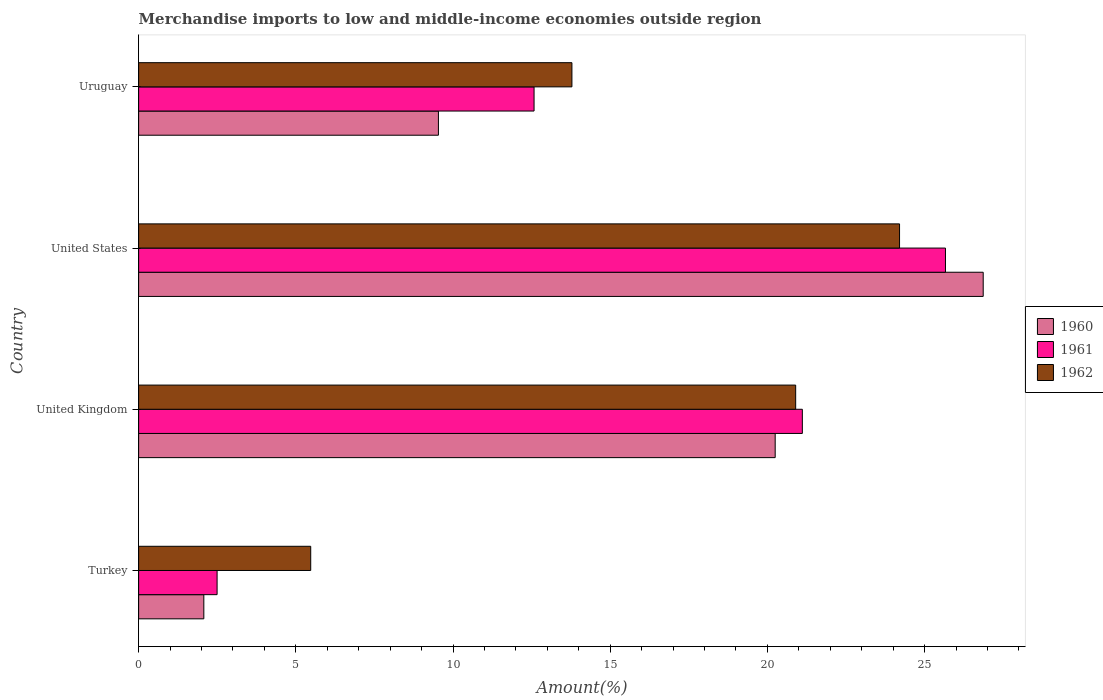How many groups of bars are there?
Your answer should be very brief. 4. How many bars are there on the 2nd tick from the top?
Offer a very short reply. 3. What is the label of the 2nd group of bars from the top?
Make the answer very short. United States. What is the percentage of amount earned from merchandise imports in 1960 in United Kingdom?
Keep it short and to the point. 20.25. Across all countries, what is the maximum percentage of amount earned from merchandise imports in 1961?
Your answer should be compact. 25.66. Across all countries, what is the minimum percentage of amount earned from merchandise imports in 1960?
Keep it short and to the point. 2.07. What is the total percentage of amount earned from merchandise imports in 1962 in the graph?
Give a very brief answer. 64.36. What is the difference between the percentage of amount earned from merchandise imports in 1960 in Turkey and that in Uruguay?
Ensure brevity in your answer.  -7.46. What is the difference between the percentage of amount earned from merchandise imports in 1961 in United States and the percentage of amount earned from merchandise imports in 1962 in Uruguay?
Ensure brevity in your answer.  11.88. What is the average percentage of amount earned from merchandise imports in 1962 per country?
Keep it short and to the point. 16.09. What is the difference between the percentage of amount earned from merchandise imports in 1960 and percentage of amount earned from merchandise imports in 1961 in Turkey?
Your answer should be very brief. -0.42. In how many countries, is the percentage of amount earned from merchandise imports in 1962 greater than 12 %?
Your answer should be very brief. 3. What is the ratio of the percentage of amount earned from merchandise imports in 1962 in United States to that in Uruguay?
Offer a terse response. 1.76. Is the percentage of amount earned from merchandise imports in 1962 in Turkey less than that in Uruguay?
Give a very brief answer. Yes. Is the difference between the percentage of amount earned from merchandise imports in 1960 in United Kingdom and Uruguay greater than the difference between the percentage of amount earned from merchandise imports in 1961 in United Kingdom and Uruguay?
Provide a succinct answer. Yes. What is the difference between the highest and the second highest percentage of amount earned from merchandise imports in 1962?
Give a very brief answer. 3.3. What is the difference between the highest and the lowest percentage of amount earned from merchandise imports in 1961?
Provide a short and direct response. 23.17. In how many countries, is the percentage of amount earned from merchandise imports in 1960 greater than the average percentage of amount earned from merchandise imports in 1960 taken over all countries?
Give a very brief answer. 2. Is the sum of the percentage of amount earned from merchandise imports in 1961 in United Kingdom and United States greater than the maximum percentage of amount earned from merchandise imports in 1960 across all countries?
Ensure brevity in your answer.  Yes. What does the 3rd bar from the bottom in United Kingdom represents?
Your answer should be compact. 1962. Is it the case that in every country, the sum of the percentage of amount earned from merchandise imports in 1962 and percentage of amount earned from merchandise imports in 1961 is greater than the percentage of amount earned from merchandise imports in 1960?
Make the answer very short. Yes. How many bars are there?
Provide a succinct answer. 12. Are all the bars in the graph horizontal?
Your response must be concise. Yes. How many countries are there in the graph?
Your answer should be very brief. 4. What is the difference between two consecutive major ticks on the X-axis?
Your answer should be compact. 5. Are the values on the major ticks of X-axis written in scientific E-notation?
Your answer should be very brief. No. Does the graph contain any zero values?
Ensure brevity in your answer.  No. Does the graph contain grids?
Your response must be concise. No. Where does the legend appear in the graph?
Give a very brief answer. Center right. What is the title of the graph?
Keep it short and to the point. Merchandise imports to low and middle-income economies outside region. Does "2010" appear as one of the legend labels in the graph?
Provide a short and direct response. No. What is the label or title of the X-axis?
Offer a terse response. Amount(%). What is the Amount(%) in 1960 in Turkey?
Ensure brevity in your answer.  2.07. What is the Amount(%) of 1961 in Turkey?
Ensure brevity in your answer.  2.5. What is the Amount(%) of 1962 in Turkey?
Your answer should be compact. 5.47. What is the Amount(%) in 1960 in United Kingdom?
Give a very brief answer. 20.25. What is the Amount(%) of 1961 in United Kingdom?
Provide a succinct answer. 21.11. What is the Amount(%) in 1962 in United Kingdom?
Keep it short and to the point. 20.9. What is the Amount(%) of 1960 in United States?
Your answer should be very brief. 26.86. What is the Amount(%) of 1961 in United States?
Your response must be concise. 25.66. What is the Amount(%) in 1962 in United States?
Provide a succinct answer. 24.2. What is the Amount(%) in 1960 in Uruguay?
Offer a terse response. 9.54. What is the Amount(%) in 1961 in Uruguay?
Your answer should be very brief. 12.58. What is the Amount(%) in 1962 in Uruguay?
Provide a succinct answer. 13.78. Across all countries, what is the maximum Amount(%) of 1960?
Offer a very short reply. 26.86. Across all countries, what is the maximum Amount(%) of 1961?
Provide a short and direct response. 25.66. Across all countries, what is the maximum Amount(%) in 1962?
Offer a terse response. 24.2. Across all countries, what is the minimum Amount(%) in 1960?
Make the answer very short. 2.07. Across all countries, what is the minimum Amount(%) in 1961?
Your answer should be very brief. 2.5. Across all countries, what is the minimum Amount(%) of 1962?
Make the answer very short. 5.47. What is the total Amount(%) of 1960 in the graph?
Keep it short and to the point. 58.72. What is the total Amount(%) of 1961 in the graph?
Your answer should be very brief. 61.85. What is the total Amount(%) of 1962 in the graph?
Give a very brief answer. 64.36. What is the difference between the Amount(%) of 1960 in Turkey and that in United Kingdom?
Your answer should be very brief. -18.17. What is the difference between the Amount(%) in 1961 in Turkey and that in United Kingdom?
Keep it short and to the point. -18.62. What is the difference between the Amount(%) of 1962 in Turkey and that in United Kingdom?
Make the answer very short. -15.43. What is the difference between the Amount(%) of 1960 in Turkey and that in United States?
Provide a succinct answer. -24.79. What is the difference between the Amount(%) of 1961 in Turkey and that in United States?
Provide a short and direct response. -23.17. What is the difference between the Amount(%) in 1962 in Turkey and that in United States?
Give a very brief answer. -18.73. What is the difference between the Amount(%) in 1960 in Turkey and that in Uruguay?
Your response must be concise. -7.46. What is the difference between the Amount(%) in 1961 in Turkey and that in Uruguay?
Keep it short and to the point. -10.08. What is the difference between the Amount(%) in 1962 in Turkey and that in Uruguay?
Keep it short and to the point. -8.31. What is the difference between the Amount(%) of 1960 in United Kingdom and that in United States?
Give a very brief answer. -6.62. What is the difference between the Amount(%) in 1961 in United Kingdom and that in United States?
Your answer should be very brief. -4.55. What is the difference between the Amount(%) of 1962 in United Kingdom and that in United States?
Make the answer very short. -3.3. What is the difference between the Amount(%) in 1960 in United Kingdom and that in Uruguay?
Offer a terse response. 10.71. What is the difference between the Amount(%) of 1961 in United Kingdom and that in Uruguay?
Your response must be concise. 8.53. What is the difference between the Amount(%) in 1962 in United Kingdom and that in Uruguay?
Keep it short and to the point. 7.12. What is the difference between the Amount(%) of 1960 in United States and that in Uruguay?
Offer a terse response. 17.33. What is the difference between the Amount(%) in 1961 in United States and that in Uruguay?
Ensure brevity in your answer.  13.09. What is the difference between the Amount(%) in 1962 in United States and that in Uruguay?
Your response must be concise. 10.42. What is the difference between the Amount(%) of 1960 in Turkey and the Amount(%) of 1961 in United Kingdom?
Your response must be concise. -19.04. What is the difference between the Amount(%) in 1960 in Turkey and the Amount(%) in 1962 in United Kingdom?
Ensure brevity in your answer.  -18.83. What is the difference between the Amount(%) in 1961 in Turkey and the Amount(%) in 1962 in United Kingdom?
Make the answer very short. -18.4. What is the difference between the Amount(%) in 1960 in Turkey and the Amount(%) in 1961 in United States?
Your answer should be very brief. -23.59. What is the difference between the Amount(%) of 1960 in Turkey and the Amount(%) of 1962 in United States?
Provide a short and direct response. -22.13. What is the difference between the Amount(%) of 1961 in Turkey and the Amount(%) of 1962 in United States?
Your answer should be compact. -21.71. What is the difference between the Amount(%) in 1960 in Turkey and the Amount(%) in 1961 in Uruguay?
Your response must be concise. -10.5. What is the difference between the Amount(%) of 1960 in Turkey and the Amount(%) of 1962 in Uruguay?
Keep it short and to the point. -11.71. What is the difference between the Amount(%) of 1961 in Turkey and the Amount(%) of 1962 in Uruguay?
Your answer should be very brief. -11.29. What is the difference between the Amount(%) in 1960 in United Kingdom and the Amount(%) in 1961 in United States?
Give a very brief answer. -5.42. What is the difference between the Amount(%) of 1960 in United Kingdom and the Amount(%) of 1962 in United States?
Ensure brevity in your answer.  -3.96. What is the difference between the Amount(%) in 1961 in United Kingdom and the Amount(%) in 1962 in United States?
Your answer should be very brief. -3.09. What is the difference between the Amount(%) of 1960 in United Kingdom and the Amount(%) of 1961 in Uruguay?
Your response must be concise. 7.67. What is the difference between the Amount(%) in 1960 in United Kingdom and the Amount(%) in 1962 in Uruguay?
Keep it short and to the point. 6.47. What is the difference between the Amount(%) of 1961 in United Kingdom and the Amount(%) of 1962 in Uruguay?
Your answer should be compact. 7.33. What is the difference between the Amount(%) in 1960 in United States and the Amount(%) in 1961 in Uruguay?
Your answer should be very brief. 14.29. What is the difference between the Amount(%) of 1960 in United States and the Amount(%) of 1962 in Uruguay?
Offer a terse response. 13.08. What is the difference between the Amount(%) in 1961 in United States and the Amount(%) in 1962 in Uruguay?
Your answer should be compact. 11.88. What is the average Amount(%) of 1960 per country?
Provide a succinct answer. 14.68. What is the average Amount(%) in 1961 per country?
Give a very brief answer. 15.46. What is the average Amount(%) in 1962 per country?
Give a very brief answer. 16.09. What is the difference between the Amount(%) of 1960 and Amount(%) of 1961 in Turkey?
Your answer should be compact. -0.42. What is the difference between the Amount(%) of 1960 and Amount(%) of 1962 in Turkey?
Ensure brevity in your answer.  -3.4. What is the difference between the Amount(%) in 1961 and Amount(%) in 1962 in Turkey?
Your response must be concise. -2.98. What is the difference between the Amount(%) in 1960 and Amount(%) in 1961 in United Kingdom?
Offer a very short reply. -0.86. What is the difference between the Amount(%) of 1960 and Amount(%) of 1962 in United Kingdom?
Provide a succinct answer. -0.65. What is the difference between the Amount(%) in 1961 and Amount(%) in 1962 in United Kingdom?
Provide a short and direct response. 0.21. What is the difference between the Amount(%) in 1960 and Amount(%) in 1961 in United States?
Your response must be concise. 1.2. What is the difference between the Amount(%) in 1960 and Amount(%) in 1962 in United States?
Offer a terse response. 2.66. What is the difference between the Amount(%) of 1961 and Amount(%) of 1962 in United States?
Your answer should be very brief. 1.46. What is the difference between the Amount(%) in 1960 and Amount(%) in 1961 in Uruguay?
Make the answer very short. -3.04. What is the difference between the Amount(%) of 1960 and Amount(%) of 1962 in Uruguay?
Make the answer very short. -4.25. What is the difference between the Amount(%) of 1961 and Amount(%) of 1962 in Uruguay?
Make the answer very short. -1.2. What is the ratio of the Amount(%) of 1960 in Turkey to that in United Kingdom?
Provide a succinct answer. 0.1. What is the ratio of the Amount(%) of 1961 in Turkey to that in United Kingdom?
Make the answer very short. 0.12. What is the ratio of the Amount(%) of 1962 in Turkey to that in United Kingdom?
Offer a very short reply. 0.26. What is the ratio of the Amount(%) of 1960 in Turkey to that in United States?
Your answer should be compact. 0.08. What is the ratio of the Amount(%) of 1961 in Turkey to that in United States?
Your response must be concise. 0.1. What is the ratio of the Amount(%) of 1962 in Turkey to that in United States?
Your response must be concise. 0.23. What is the ratio of the Amount(%) in 1960 in Turkey to that in Uruguay?
Offer a very short reply. 0.22. What is the ratio of the Amount(%) of 1961 in Turkey to that in Uruguay?
Offer a very short reply. 0.2. What is the ratio of the Amount(%) in 1962 in Turkey to that in Uruguay?
Your answer should be very brief. 0.4. What is the ratio of the Amount(%) of 1960 in United Kingdom to that in United States?
Provide a succinct answer. 0.75. What is the ratio of the Amount(%) in 1961 in United Kingdom to that in United States?
Provide a short and direct response. 0.82. What is the ratio of the Amount(%) in 1962 in United Kingdom to that in United States?
Provide a short and direct response. 0.86. What is the ratio of the Amount(%) in 1960 in United Kingdom to that in Uruguay?
Make the answer very short. 2.12. What is the ratio of the Amount(%) of 1961 in United Kingdom to that in Uruguay?
Keep it short and to the point. 1.68. What is the ratio of the Amount(%) of 1962 in United Kingdom to that in Uruguay?
Offer a very short reply. 1.52. What is the ratio of the Amount(%) in 1960 in United States to that in Uruguay?
Make the answer very short. 2.82. What is the ratio of the Amount(%) in 1961 in United States to that in Uruguay?
Give a very brief answer. 2.04. What is the ratio of the Amount(%) in 1962 in United States to that in Uruguay?
Give a very brief answer. 1.76. What is the difference between the highest and the second highest Amount(%) of 1960?
Ensure brevity in your answer.  6.62. What is the difference between the highest and the second highest Amount(%) in 1961?
Provide a short and direct response. 4.55. What is the difference between the highest and the second highest Amount(%) in 1962?
Your answer should be compact. 3.3. What is the difference between the highest and the lowest Amount(%) of 1960?
Provide a succinct answer. 24.79. What is the difference between the highest and the lowest Amount(%) in 1961?
Your answer should be very brief. 23.17. What is the difference between the highest and the lowest Amount(%) of 1962?
Ensure brevity in your answer.  18.73. 